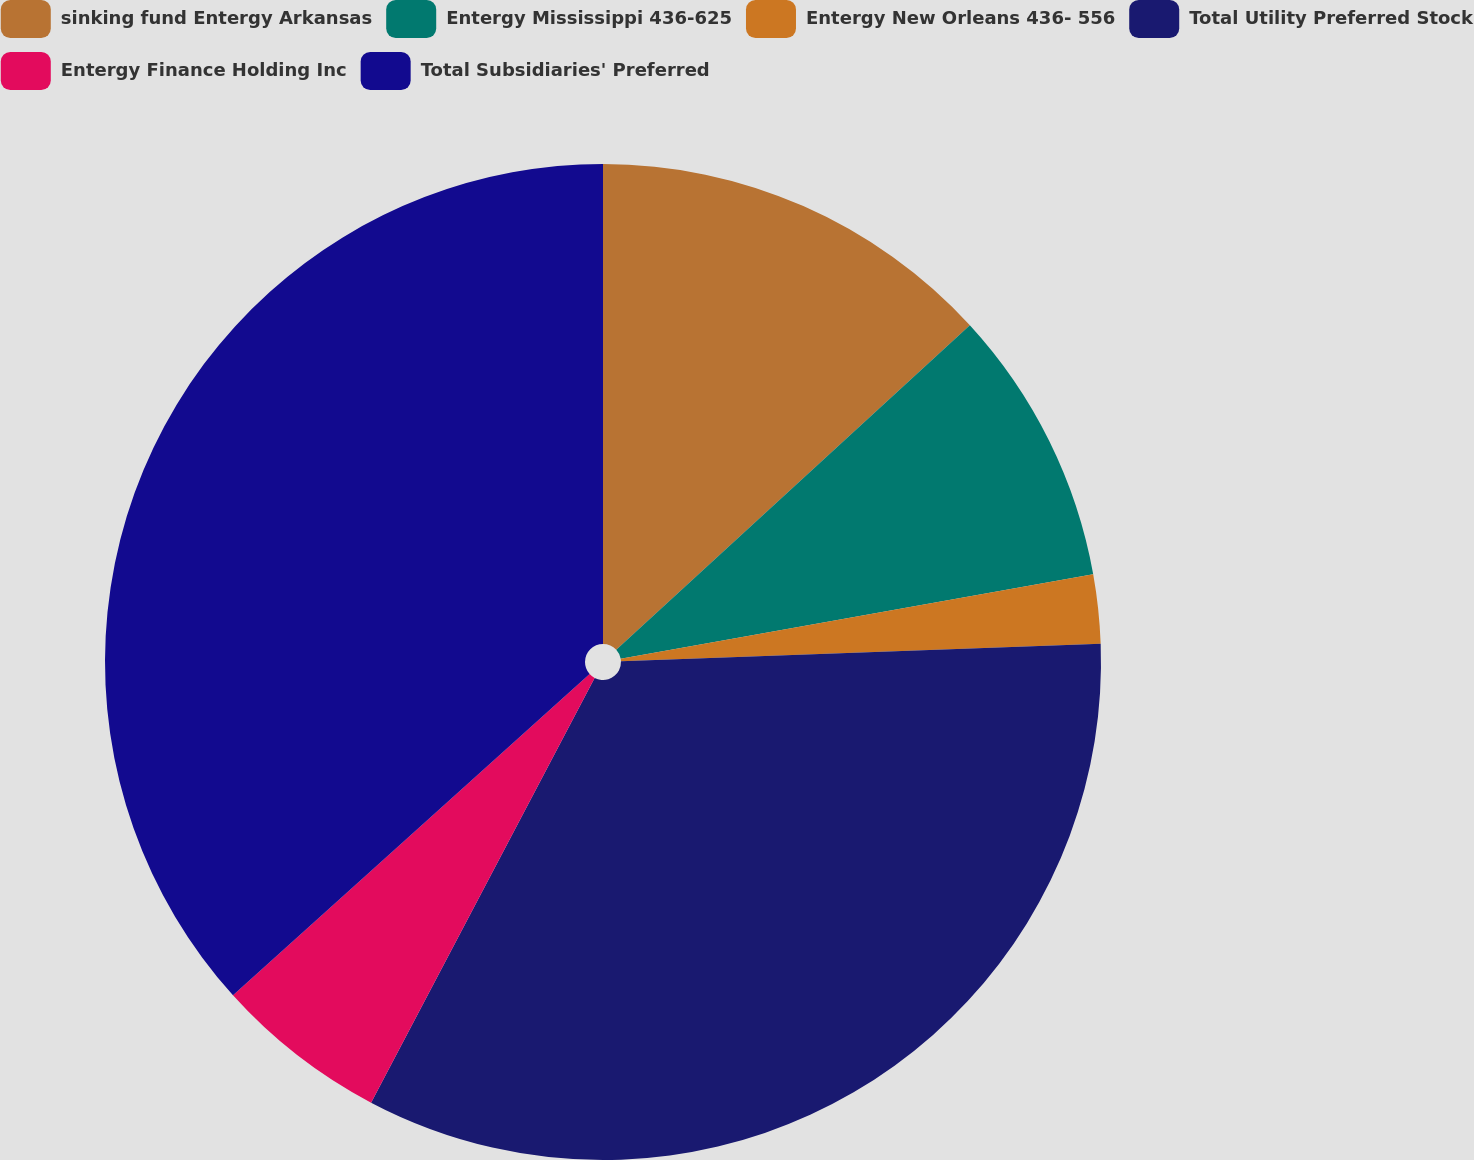<chart> <loc_0><loc_0><loc_500><loc_500><pie_chart><fcel>sinking fund Entergy Arkansas<fcel>Entergy Mississippi 436-625<fcel>Entergy New Orleans 436- 556<fcel>Total Utility Preferred Stock<fcel>Entergy Finance Holding Inc<fcel>Total Subsidiaries' Preferred<nl><fcel>13.18%<fcel>9.0%<fcel>2.24%<fcel>33.29%<fcel>5.62%<fcel>36.67%<nl></chart> 